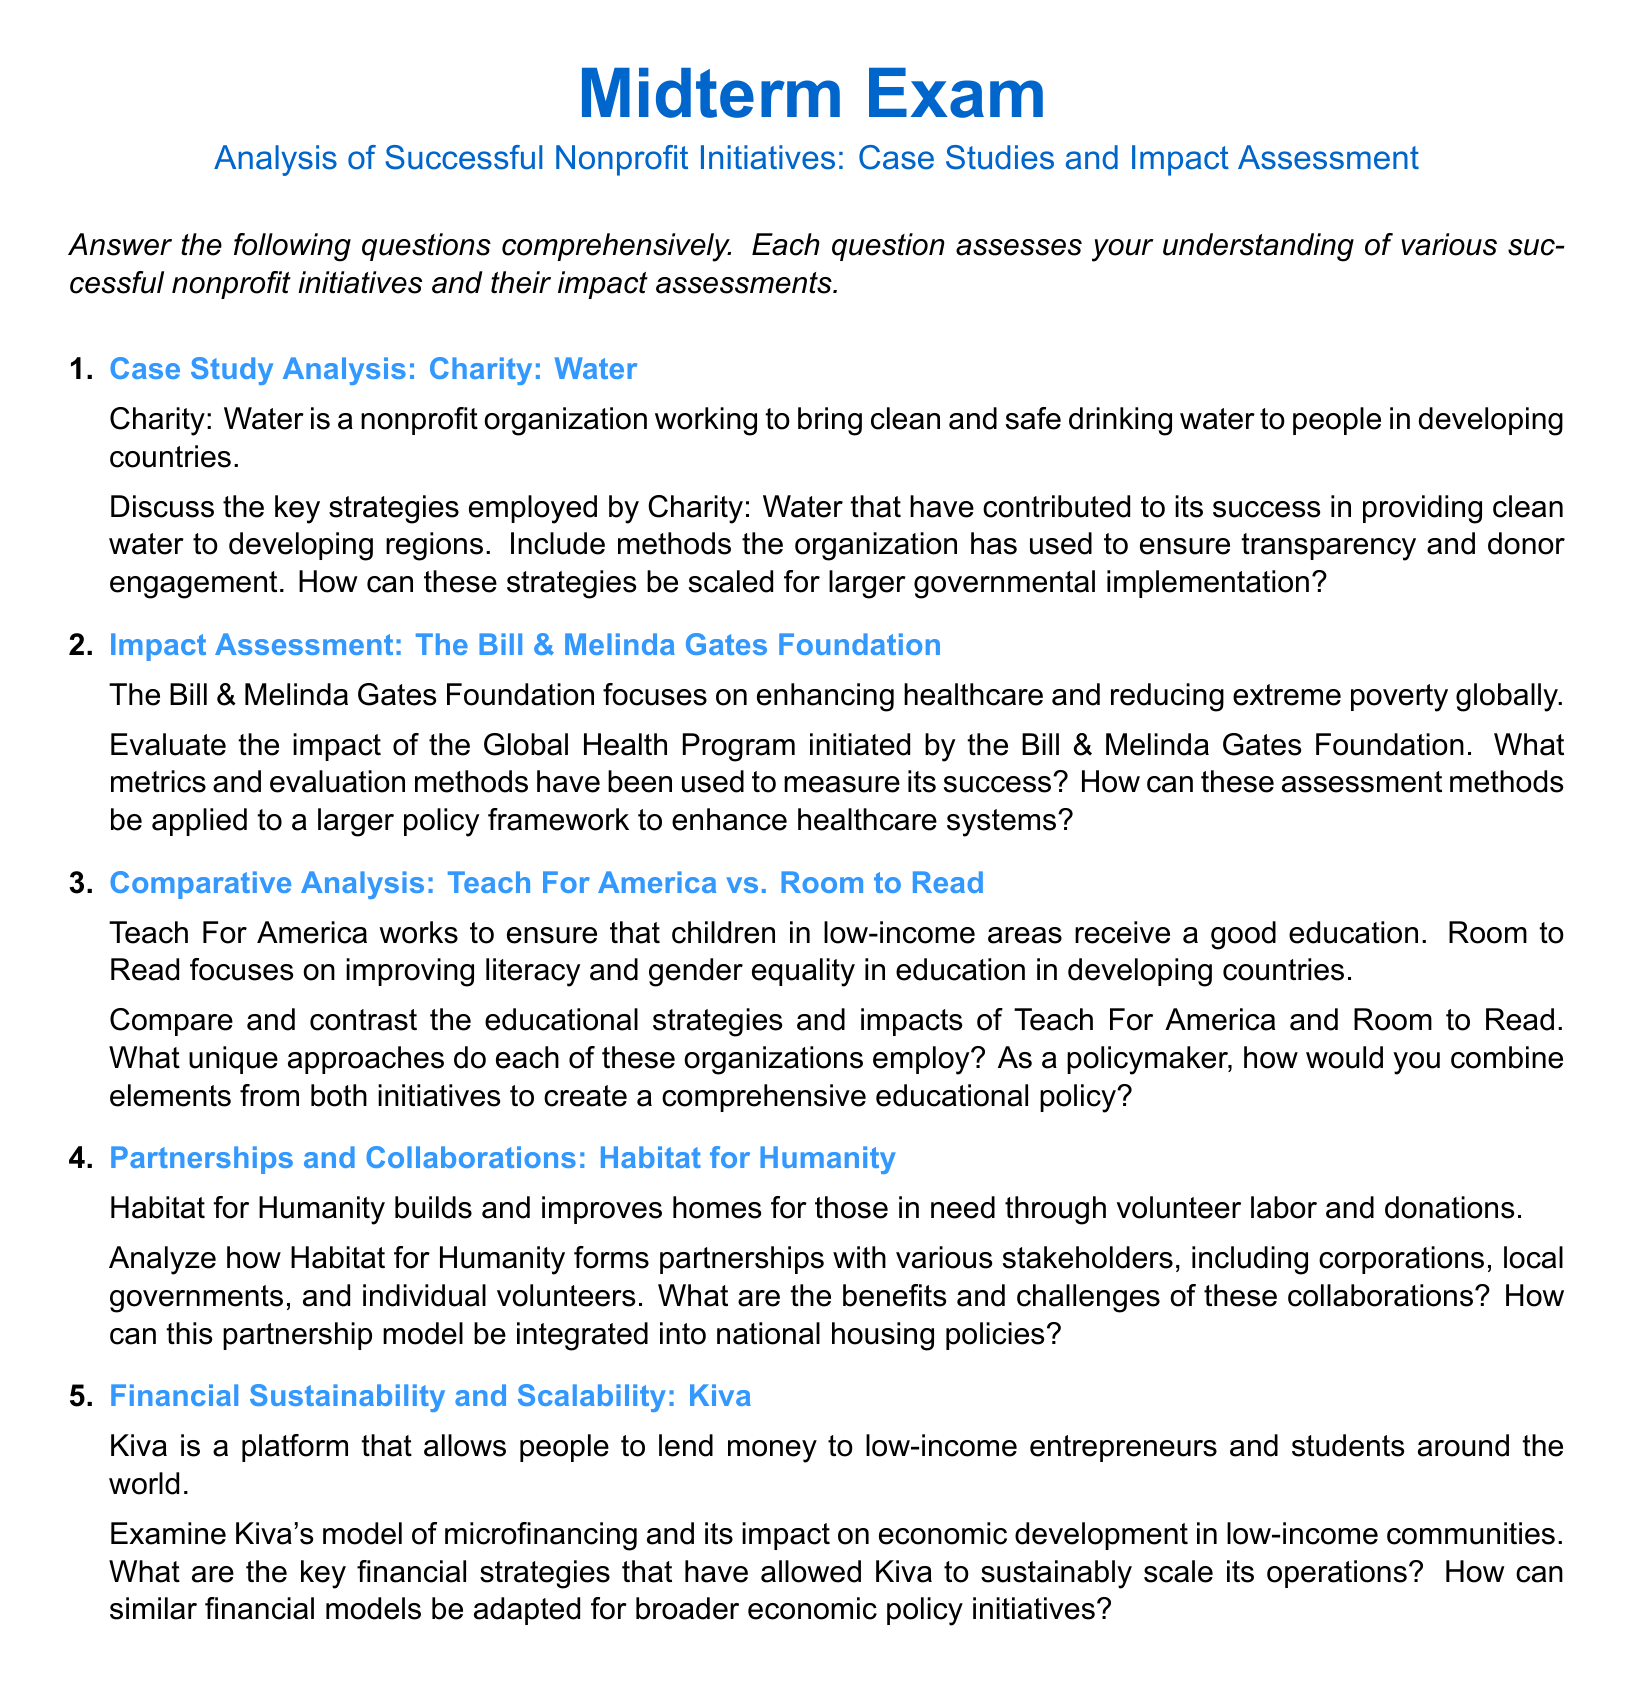What is the focus of Charity: Water? Charity: Water is a nonprofit organization that works to bring clean and safe drinking water to people in developing countries.
Answer: Clean and safe drinking water What is the primary goal of the Bill & Melinda Gates Foundation? The Bill & Melinda Gates Foundation focuses on enhancing healthcare and reducing extreme poverty globally.
Answer: Enhancing healthcare and reducing extreme poverty Which two organizations are compared in the third question? The third question compares Teach For America and Room to Read.
Answer: Teach For America and Room to Read What organization is known for building homes through volunteer labor? The organization known for building homes through volunteer labor is Habitat for Humanity.
Answer: Habitat for Humanity What financing model does Kiva utilize to support entrepreneurs? Kiva utilizes a microfinancing model to allow people to lend money to low-income entrepreneurs.
Answer: Microfinancing How many questions are included in the midterm exam? The document lists five questions in the midterm exam.
Answer: Five What is the title of the midterm exam? The title of the midterm exam is "Analysis of Successful Nonprofit Initiatives: Case Studies and Impact Assessment."
Answer: Analysis of Successful Nonprofit Initiatives: Case Studies and Impact Assessment What strategy is mentioned as a method for ensuring transparency and donor engagement by Charity: Water? The document does not specify a particular strategy but implies there are methods used to ensure transparency and donor engagement.
Answer: Methods to ensure transparency and donor engagement Which aspect of Kiva's operations is emphasized in its impact on economic development? The impact of Kiva emphasizes its model of microfinancing on economic development in low-income communities.
Answer: Model of microfinancing What stakeholder types does Habitat for Humanity form partnerships with? Habitat for Humanity forms partnerships with corporations, local governments, and individual volunteers.
Answer: Corporations, local governments, individual volunteers 